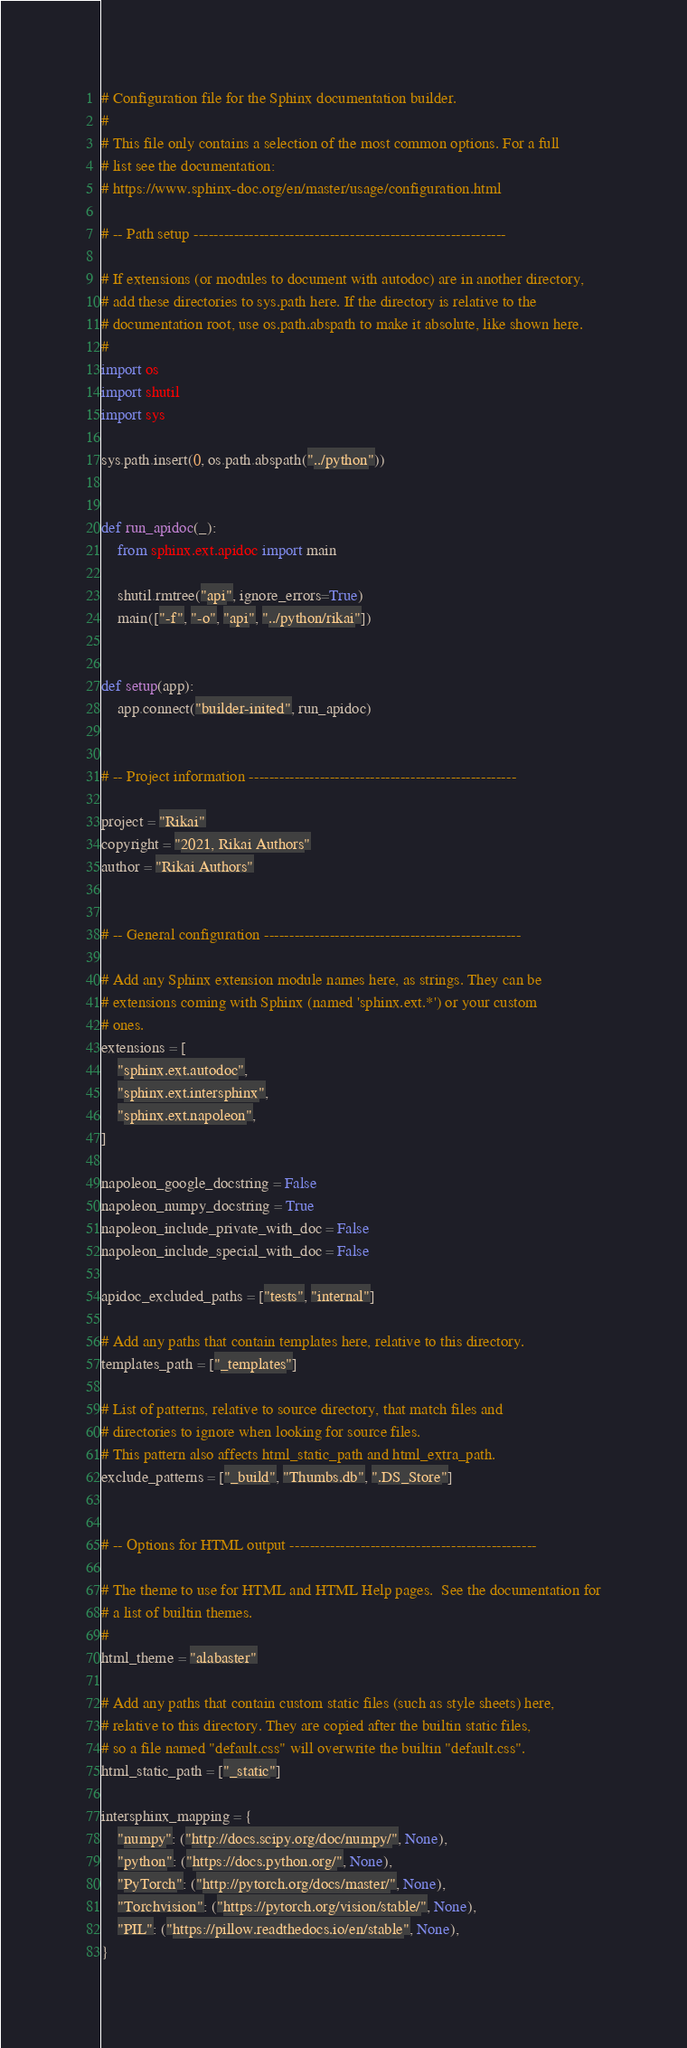<code> <loc_0><loc_0><loc_500><loc_500><_Python_># Configuration file for the Sphinx documentation builder.
#
# This file only contains a selection of the most common options. For a full
# list see the documentation:
# https://www.sphinx-doc.org/en/master/usage/configuration.html

# -- Path setup --------------------------------------------------------------

# If extensions (or modules to document with autodoc) are in another directory,
# add these directories to sys.path here. If the directory is relative to the
# documentation root, use os.path.abspath to make it absolute, like shown here.
#
import os
import shutil
import sys

sys.path.insert(0, os.path.abspath("../python"))


def run_apidoc(_):
    from sphinx.ext.apidoc import main

    shutil.rmtree("api", ignore_errors=True)
    main(["-f", "-o", "api", "../python/rikai"])


def setup(app):
    app.connect("builder-inited", run_apidoc)


# -- Project information -----------------------------------------------------

project = "Rikai"
copyright = "2021, Rikai Authors"
author = "Rikai Authors"


# -- General configuration ---------------------------------------------------

# Add any Sphinx extension module names here, as strings. They can be
# extensions coming with Sphinx (named 'sphinx.ext.*') or your custom
# ones.
extensions = [
    "sphinx.ext.autodoc",
    "sphinx.ext.intersphinx",
    "sphinx.ext.napoleon",
]

napoleon_google_docstring = False
napoleon_numpy_docstring = True
napoleon_include_private_with_doc = False
napoleon_include_special_with_doc = False

apidoc_excluded_paths = ["tests", "internal"]

# Add any paths that contain templates here, relative to this directory.
templates_path = ["_templates"]

# List of patterns, relative to source directory, that match files and
# directories to ignore when looking for source files.
# This pattern also affects html_static_path and html_extra_path.
exclude_patterns = ["_build", "Thumbs.db", ".DS_Store"]


# -- Options for HTML output -------------------------------------------------

# The theme to use for HTML and HTML Help pages.  See the documentation for
# a list of builtin themes.
#
html_theme = "alabaster"

# Add any paths that contain custom static files (such as style sheets) here,
# relative to this directory. They are copied after the builtin static files,
# so a file named "default.css" will overwrite the builtin "default.css".
html_static_path = ["_static"]

intersphinx_mapping = {
    "numpy": ("http://docs.scipy.org/doc/numpy/", None),
    "python": ("https://docs.python.org/", None),
    "PyTorch": ("http://pytorch.org/docs/master/", None),
    "Torchvision": ("https://pytorch.org/vision/stable/", None),
    "PIL": ("https://pillow.readthedocs.io/en/stable", None),
}
</code> 